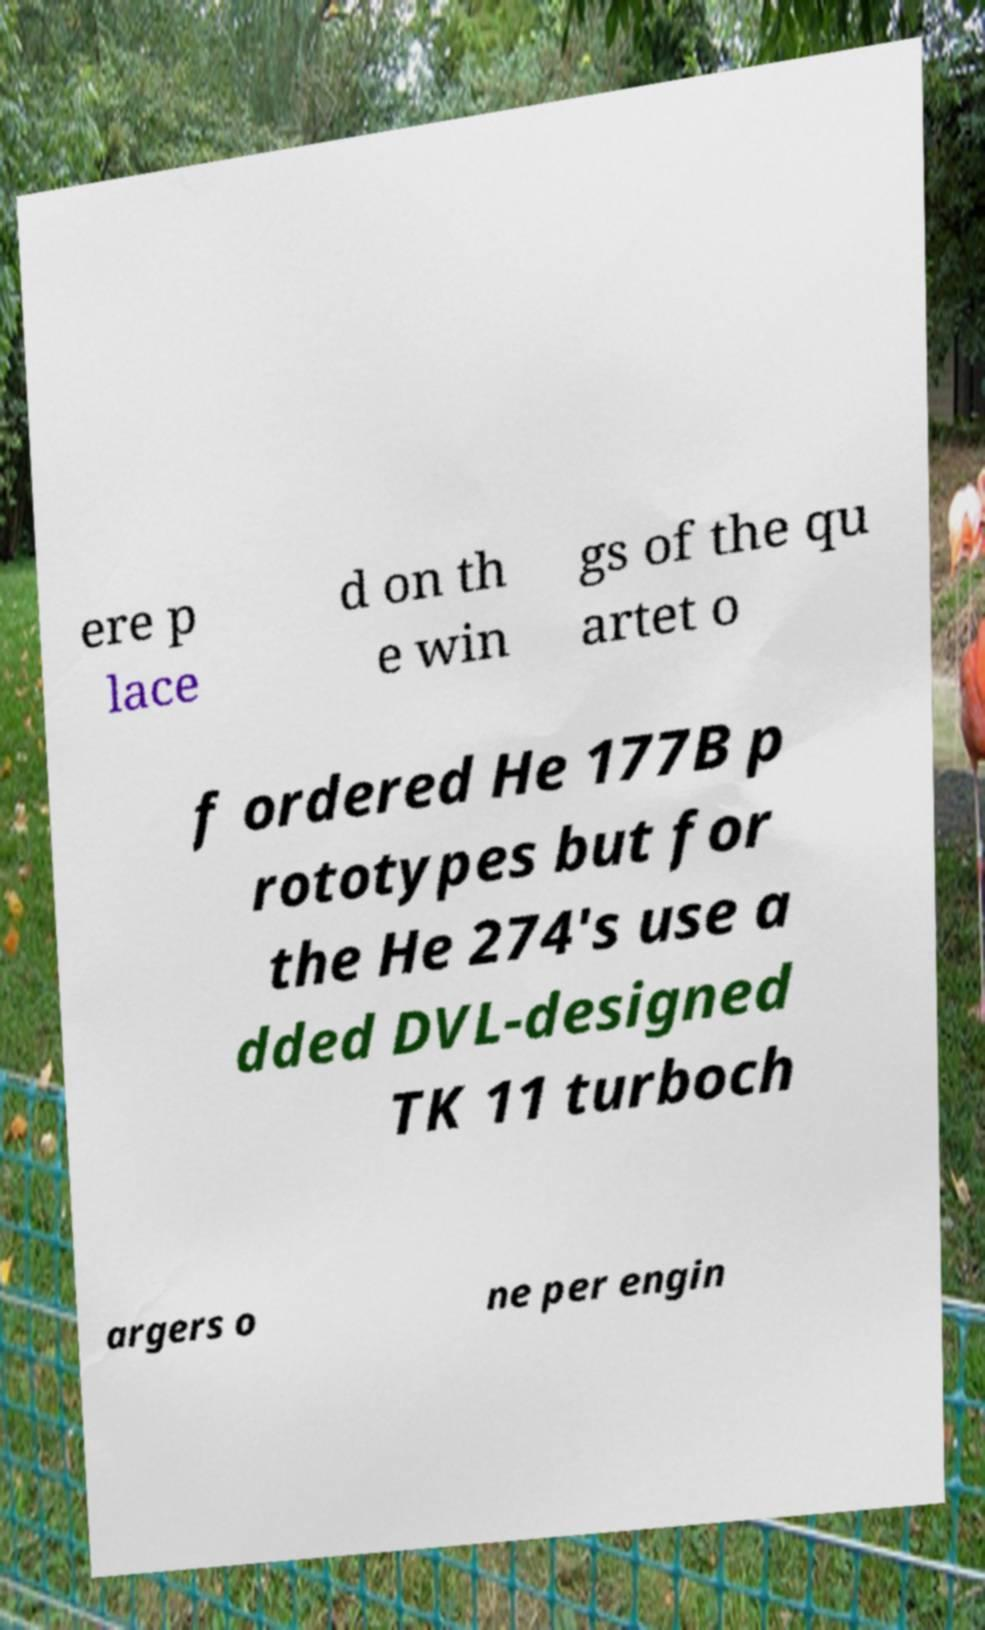For documentation purposes, I need the text within this image transcribed. Could you provide that? ere p lace d on th e win gs of the qu artet o f ordered He 177B p rototypes but for the He 274's use a dded DVL-designed TK 11 turboch argers o ne per engin 